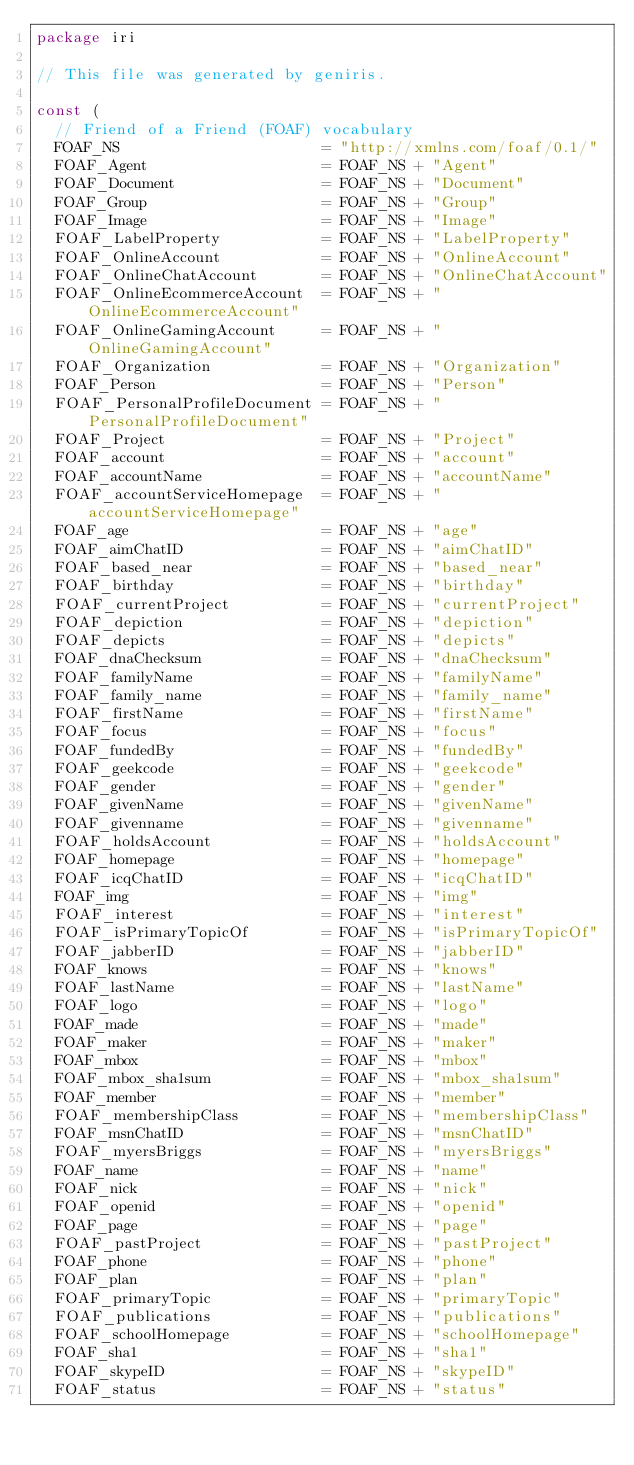Convert code to text. <code><loc_0><loc_0><loc_500><loc_500><_Go_>package iri

// This file was generated by geniris.

const (
	// Friend of a Friend (FOAF) vocabulary
	FOAF_NS                      = "http://xmlns.com/foaf/0.1/"
	FOAF_Agent                   = FOAF_NS + "Agent"
	FOAF_Document                = FOAF_NS + "Document"
	FOAF_Group                   = FOAF_NS + "Group"
	FOAF_Image                   = FOAF_NS + "Image"
	FOAF_LabelProperty           = FOAF_NS + "LabelProperty"
	FOAF_OnlineAccount           = FOAF_NS + "OnlineAccount"
	FOAF_OnlineChatAccount       = FOAF_NS + "OnlineChatAccount"
	FOAF_OnlineEcommerceAccount  = FOAF_NS + "OnlineEcommerceAccount"
	FOAF_OnlineGamingAccount     = FOAF_NS + "OnlineGamingAccount"
	FOAF_Organization            = FOAF_NS + "Organization"
	FOAF_Person                  = FOAF_NS + "Person"
	FOAF_PersonalProfileDocument = FOAF_NS + "PersonalProfileDocument"
	FOAF_Project                 = FOAF_NS + "Project"
	FOAF_account                 = FOAF_NS + "account"
	FOAF_accountName             = FOAF_NS + "accountName"
	FOAF_accountServiceHomepage  = FOAF_NS + "accountServiceHomepage"
	FOAF_age                     = FOAF_NS + "age"
	FOAF_aimChatID               = FOAF_NS + "aimChatID"
	FOAF_based_near              = FOAF_NS + "based_near"
	FOAF_birthday                = FOAF_NS + "birthday"
	FOAF_currentProject          = FOAF_NS + "currentProject"
	FOAF_depiction               = FOAF_NS + "depiction"
	FOAF_depicts                 = FOAF_NS + "depicts"
	FOAF_dnaChecksum             = FOAF_NS + "dnaChecksum"
	FOAF_familyName              = FOAF_NS + "familyName"
	FOAF_family_name             = FOAF_NS + "family_name"
	FOAF_firstName               = FOAF_NS + "firstName"
	FOAF_focus                   = FOAF_NS + "focus"
	FOAF_fundedBy                = FOAF_NS + "fundedBy"
	FOAF_geekcode                = FOAF_NS + "geekcode"
	FOAF_gender                  = FOAF_NS + "gender"
	FOAF_givenName               = FOAF_NS + "givenName"
	FOAF_givenname               = FOAF_NS + "givenname"
	FOAF_holdsAccount            = FOAF_NS + "holdsAccount"
	FOAF_homepage                = FOAF_NS + "homepage"
	FOAF_icqChatID               = FOAF_NS + "icqChatID"
	FOAF_img                     = FOAF_NS + "img"
	FOAF_interest                = FOAF_NS + "interest"
	FOAF_isPrimaryTopicOf        = FOAF_NS + "isPrimaryTopicOf"
	FOAF_jabberID                = FOAF_NS + "jabberID"
	FOAF_knows                   = FOAF_NS + "knows"
	FOAF_lastName                = FOAF_NS + "lastName"
	FOAF_logo                    = FOAF_NS + "logo"
	FOAF_made                    = FOAF_NS + "made"
	FOAF_maker                   = FOAF_NS + "maker"
	FOAF_mbox                    = FOAF_NS + "mbox"
	FOAF_mbox_sha1sum            = FOAF_NS + "mbox_sha1sum"
	FOAF_member                  = FOAF_NS + "member"
	FOAF_membershipClass         = FOAF_NS + "membershipClass"
	FOAF_msnChatID               = FOAF_NS + "msnChatID"
	FOAF_myersBriggs             = FOAF_NS + "myersBriggs"
	FOAF_name                    = FOAF_NS + "name"
	FOAF_nick                    = FOAF_NS + "nick"
	FOAF_openid                  = FOAF_NS + "openid"
	FOAF_page                    = FOAF_NS + "page"
	FOAF_pastProject             = FOAF_NS + "pastProject"
	FOAF_phone                   = FOAF_NS + "phone"
	FOAF_plan                    = FOAF_NS + "plan"
	FOAF_primaryTopic            = FOAF_NS + "primaryTopic"
	FOAF_publications            = FOAF_NS + "publications"
	FOAF_schoolHomepage          = FOAF_NS + "schoolHomepage"
	FOAF_sha1                    = FOAF_NS + "sha1"
	FOAF_skypeID                 = FOAF_NS + "skypeID"
	FOAF_status                  = FOAF_NS + "status"</code> 